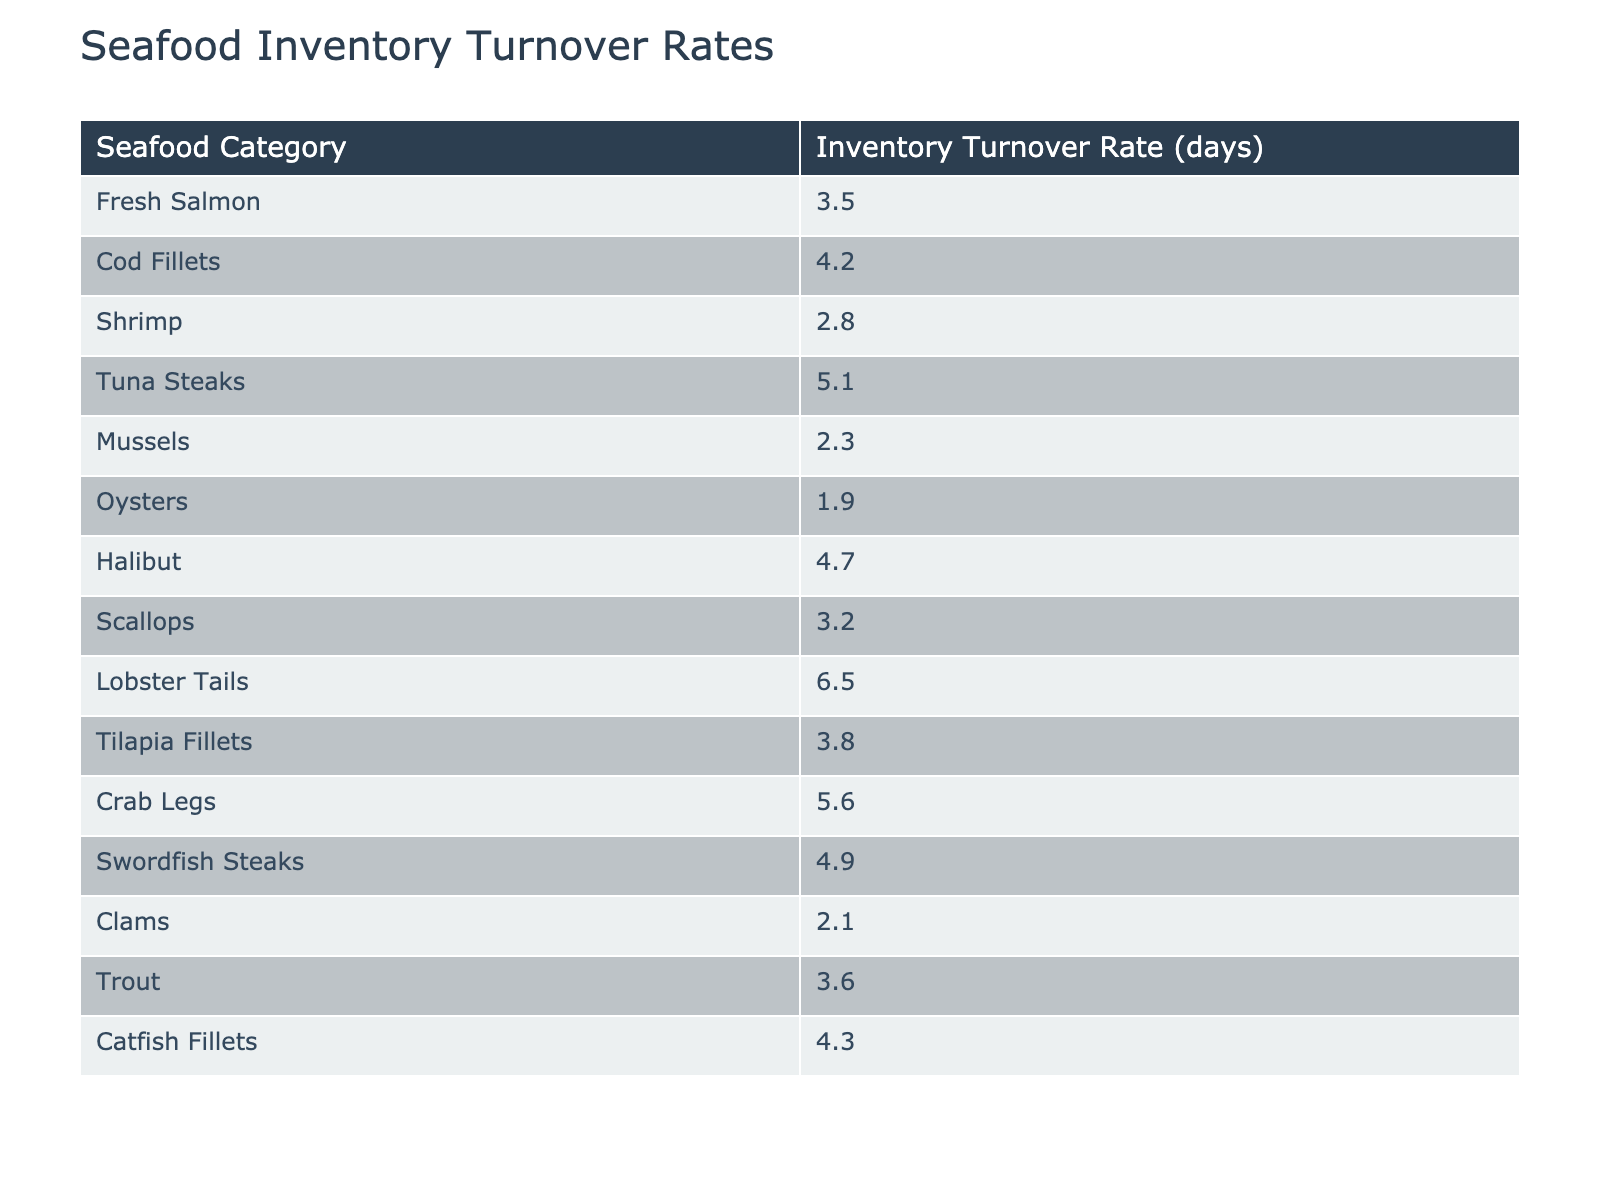What's the inventory turnover rate for Oysters? The table shows that the turnover rate specifically for Oysters is listed as 1.9 days.
Answer: 1.9 Which seafood category has the lowest inventory turnover rate? Examining the table, Oysters has the lowest turnover rate at 1.9 days, making it the category with the slowest turnover.
Answer: Oysters What is the inventory turnover rate for Scallops? The table indicates that Scallops have an inventory turnover rate of 3.2 days.
Answer: 3.2 What seafood category has a turnover rate greater than 4 days? From the table, the categories with turnover rates greater than 4 days are Tuna Steaks (5.1), Halibut (4.7), Crab Legs (5.6), and Swordfish Steaks (4.9).
Answer: Tuna Steaks, Halibut, Crab Legs, Swordfish Steaks What is the average inventory turnover rate for all seafood categories? To find the average, sum the individual turnover rates (3.5 + 4.2 + 2.8 + 5.1 + 2.3 + 1.9 + 4.7 + 3.2 + 6.5 + 3.8 + 5.6 + 4.9 + 2.1 + 3.6 + 4.3 = 56.3) and divide by the number of categories (15). The average is 56.3 / 15 = 3.75 days.
Answer: 3.75 Is the inventory turnover rate for Fresh Salmon higher than for Shrimp? The turnover rate for Fresh Salmon is 3.5 days, while Shrimp has a rate of 2.8 days. Since 3.5 is greater than 2.8, the statement is true.
Answer: Yes Which seafood category has the highest inventory turnover rate? By reviewing the table, it's clear that Lobster Tails have the highest turnover rate at 6.5 days.
Answer: Lobster Tails What is the difference in inventory turnover rate between Crab Legs and Mussels? The turnover rate for Crab Legs is 5.6 days, while for Mussels it is 2.3 days. The difference is 5.6 - 2.3 = 3.3 days.
Answer: 3.3 If we exclude the top three highest turnover rates, what is the average of the remaining categories? The top three categories (Lobster Tails, Crab Legs, and Tuna Steaks) are 6.5, 5.6, and 5.1 respectively. Excluding these, we have the remaining rates: (3.5 + 4.2 + 2.8 + 4.7 + 3.2 + 1.9 + 4.3 + 2.1 + 3.6). This sums to 30.3 over 12 categories, giving an average of 30.3 / 12 = 2.525 days.
Answer: 2.525 Are there any seafood categories with an inventory turnover rate lower than 3 days? Reviewing the table reveals that the categories with rates lower than 3 days are Oysters (1.9), Mussels (2.3), and Clams (2.1). Therefore, the answer is yes.
Answer: Yes 